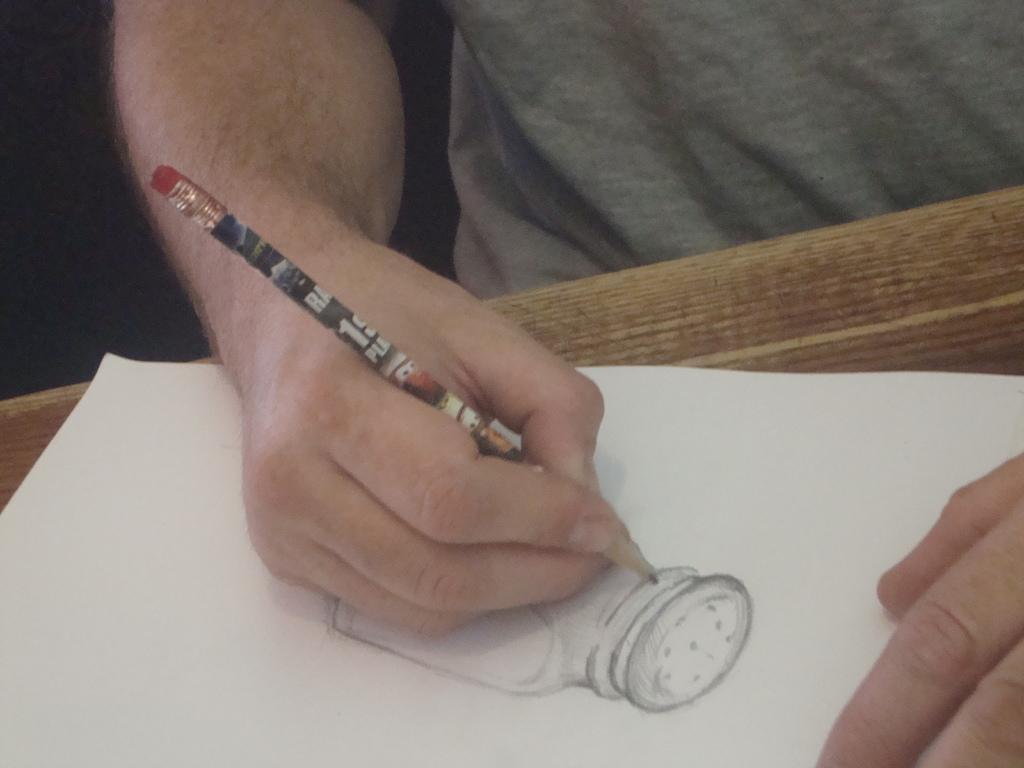How would you summarize this image in a sentence or two? In this image I can see a person holding a pencil and drawing on a paper. 